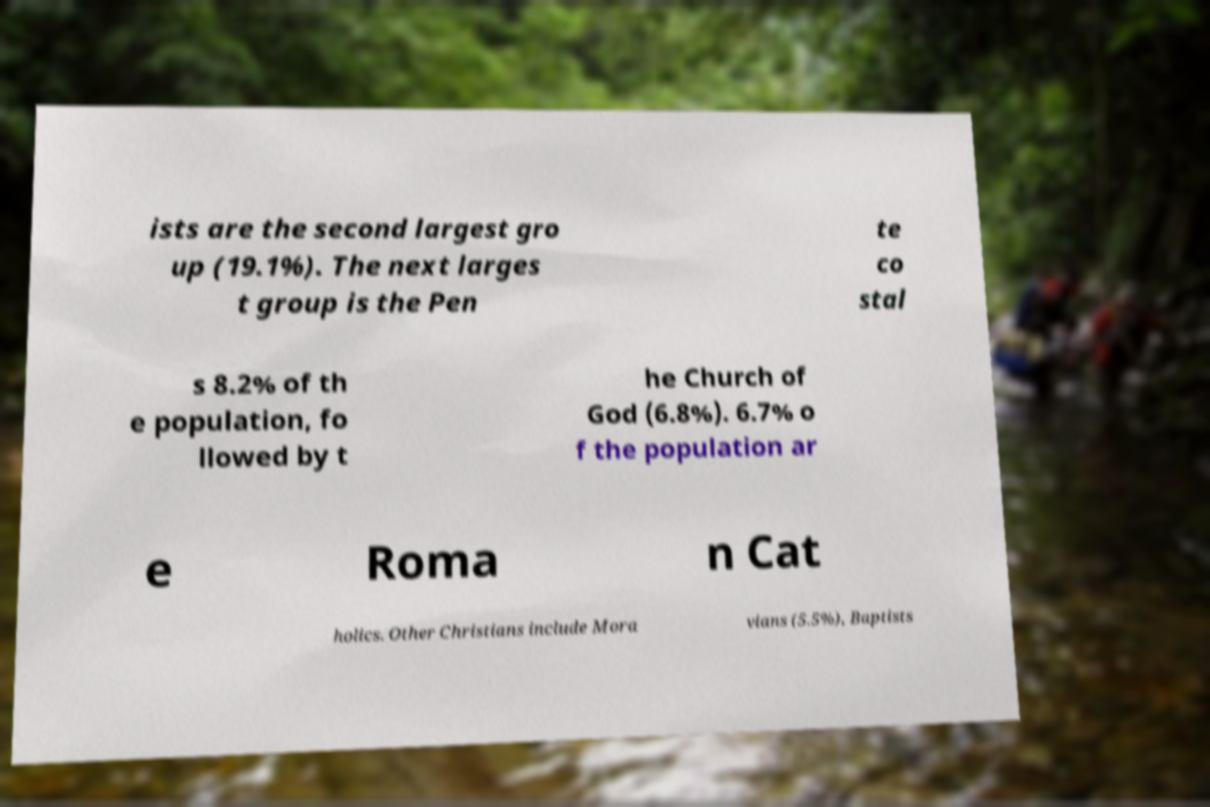Please identify and transcribe the text found in this image. ists are the second largest gro up (19.1%). The next larges t group is the Pen te co stal s 8.2% of th e population, fo llowed by t he Church of God (6.8%). 6.7% o f the population ar e Roma n Cat holics. Other Christians include Mora vians (5.5%), Baptists 